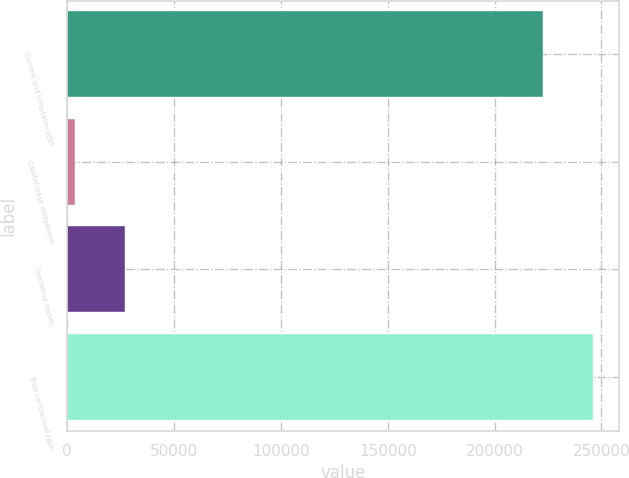Convert chart to OTSL. <chart><loc_0><loc_0><loc_500><loc_500><bar_chart><fcel>Current and long-term debt<fcel>Capital lease obligations<fcel>Operating leases<fcel>Total contractual cash<nl><fcel>222839<fcel>3869<fcel>27064<fcel>246034<nl></chart> 